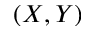<formula> <loc_0><loc_0><loc_500><loc_500>( X , Y )</formula> 